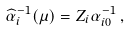<formula> <loc_0><loc_0><loc_500><loc_500>\widehat { \alpha } _ { i } ^ { - 1 } ( \mu ) = Z _ { i } \alpha _ { i 0 } ^ { - 1 } \, ,</formula> 